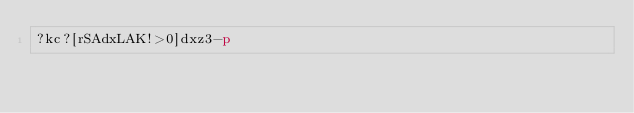<code> <loc_0><loc_0><loc_500><loc_500><_dc_>?kc?[rSAdxLAK!>0]dxz3-p</code> 